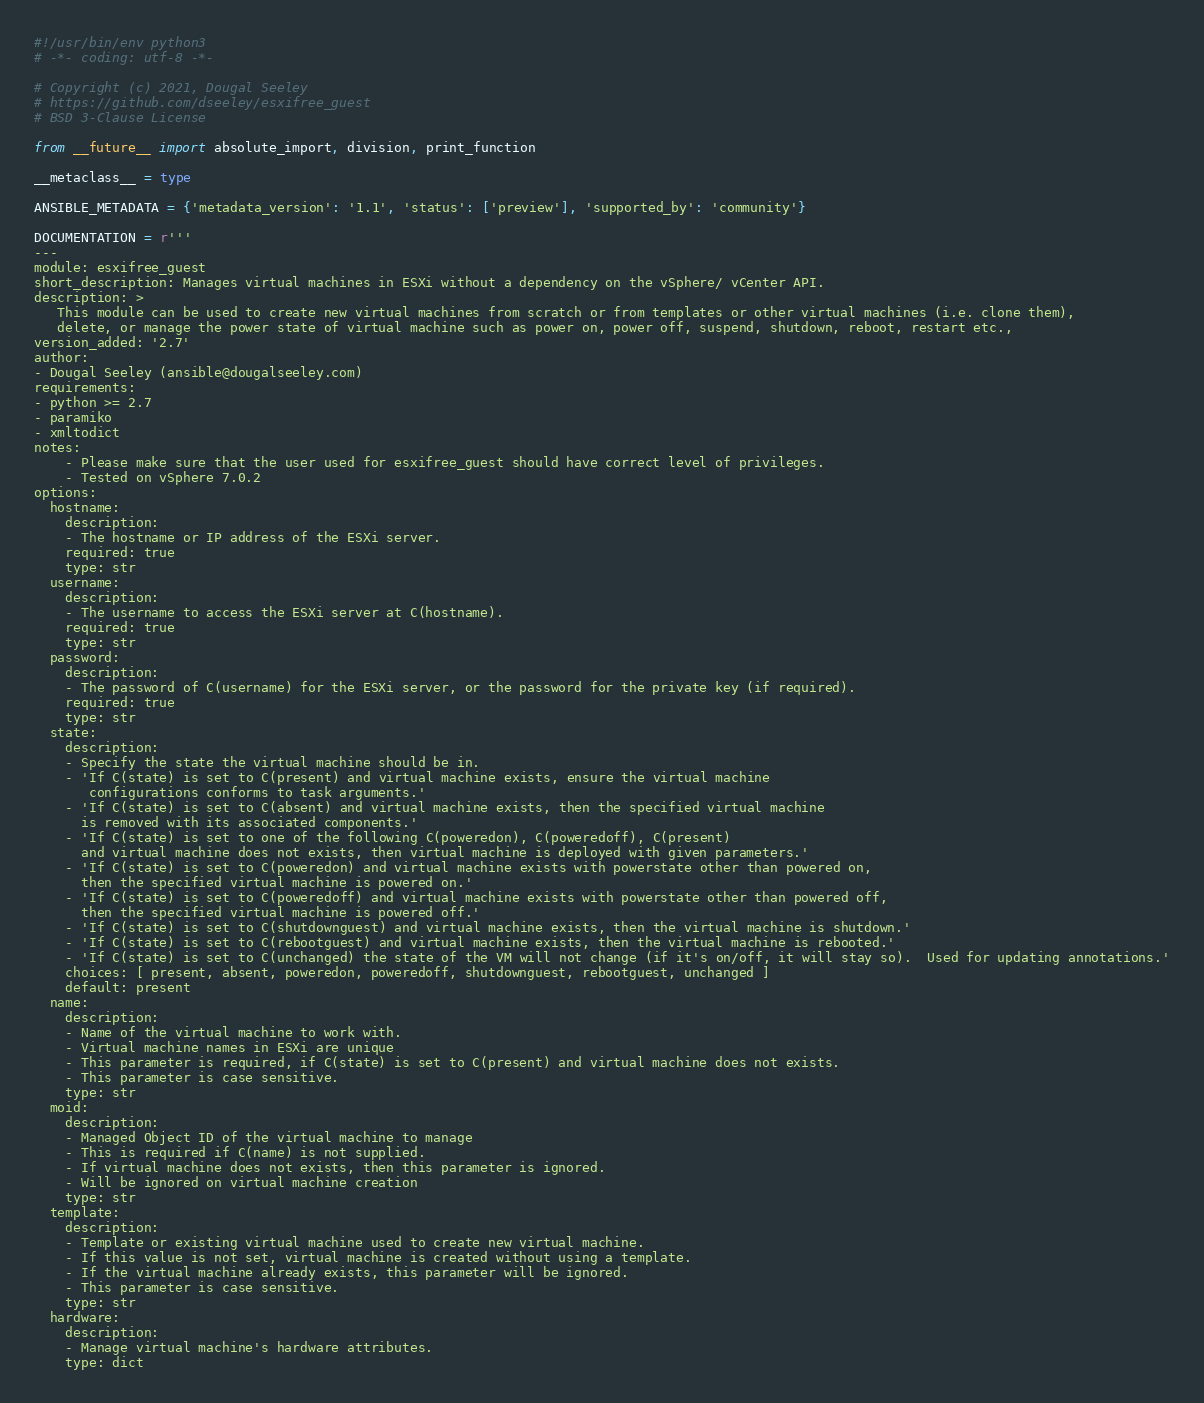Convert code to text. <code><loc_0><loc_0><loc_500><loc_500><_Python_>#!/usr/bin/env python3
# -*- coding: utf-8 -*-

# Copyright (c) 2021, Dougal Seeley
# https://github.com/dseeley/esxifree_guest
# BSD 3-Clause License

from __future__ import absolute_import, division, print_function

__metaclass__ = type

ANSIBLE_METADATA = {'metadata_version': '1.1', 'status': ['preview'], 'supported_by': 'community'}

DOCUMENTATION = r'''
---
module: esxifree_guest
short_description: Manages virtual machines in ESXi without a dependency on the vSphere/ vCenter API.
description: >
   This module can be used to create new virtual machines from scratch or from templates or other virtual machines (i.e. clone them),
   delete, or manage the power state of virtual machine such as power on, power off, suspend, shutdown, reboot, restart etc.,
version_added: '2.7'
author:
- Dougal Seeley (ansible@dougalseeley.com)
requirements:
- python >= 2.7
- paramiko
- xmltodict
notes:
    - Please make sure that the user used for esxifree_guest should have correct level of privileges.
    - Tested on vSphere 7.0.2
options:
  hostname:
    description:
    - The hostname or IP address of the ESXi server.
    required: true
    type: str
  username:
    description:
    - The username to access the ESXi server at C(hostname).
    required: true
    type: str
  password:
    description:
    - The password of C(username) for the ESXi server, or the password for the private key (if required).
    required: true
    type: str
  state:
    description:
    - Specify the state the virtual machine should be in.
    - 'If C(state) is set to C(present) and virtual machine exists, ensure the virtual machine
       configurations conforms to task arguments.'
    - 'If C(state) is set to C(absent) and virtual machine exists, then the specified virtual machine
      is removed with its associated components.'
    - 'If C(state) is set to one of the following C(poweredon), C(poweredoff), C(present)
      and virtual machine does not exists, then virtual machine is deployed with given parameters.'
    - 'If C(state) is set to C(poweredon) and virtual machine exists with powerstate other than powered on,
      then the specified virtual machine is powered on.'
    - 'If C(state) is set to C(poweredoff) and virtual machine exists with powerstate other than powered off,
      then the specified virtual machine is powered off.'
    - 'If C(state) is set to C(shutdownguest) and virtual machine exists, then the virtual machine is shutdown.'
    - 'If C(state) is set to C(rebootguest) and virtual machine exists, then the virtual machine is rebooted.'
    - 'If C(state) is set to C(unchanged) the state of the VM will not change (if it's on/off, it will stay so).  Used for updating annotations.'
    choices: [ present, absent, poweredon, poweredoff, shutdownguest, rebootguest, unchanged ]
    default: present
  name:
    description:
    - Name of the virtual machine to work with.
    - Virtual machine names in ESXi are unique
    - This parameter is required, if C(state) is set to C(present) and virtual machine does not exists.
    - This parameter is case sensitive.
    type: str
  moid:
    description:
    - Managed Object ID of the virtual machine to manage
    - This is required if C(name) is not supplied.
    - If virtual machine does not exists, then this parameter is ignored.
    - Will be ignored on virtual machine creation
    type: str
  template:
    description:
    - Template or existing virtual machine used to create new virtual machine.
    - If this value is not set, virtual machine is created without using a template.
    - If the virtual machine already exists, this parameter will be ignored.
    - This parameter is case sensitive.
    type: str
  hardware:
    description:
    - Manage virtual machine's hardware attributes.
    type: dict</code> 